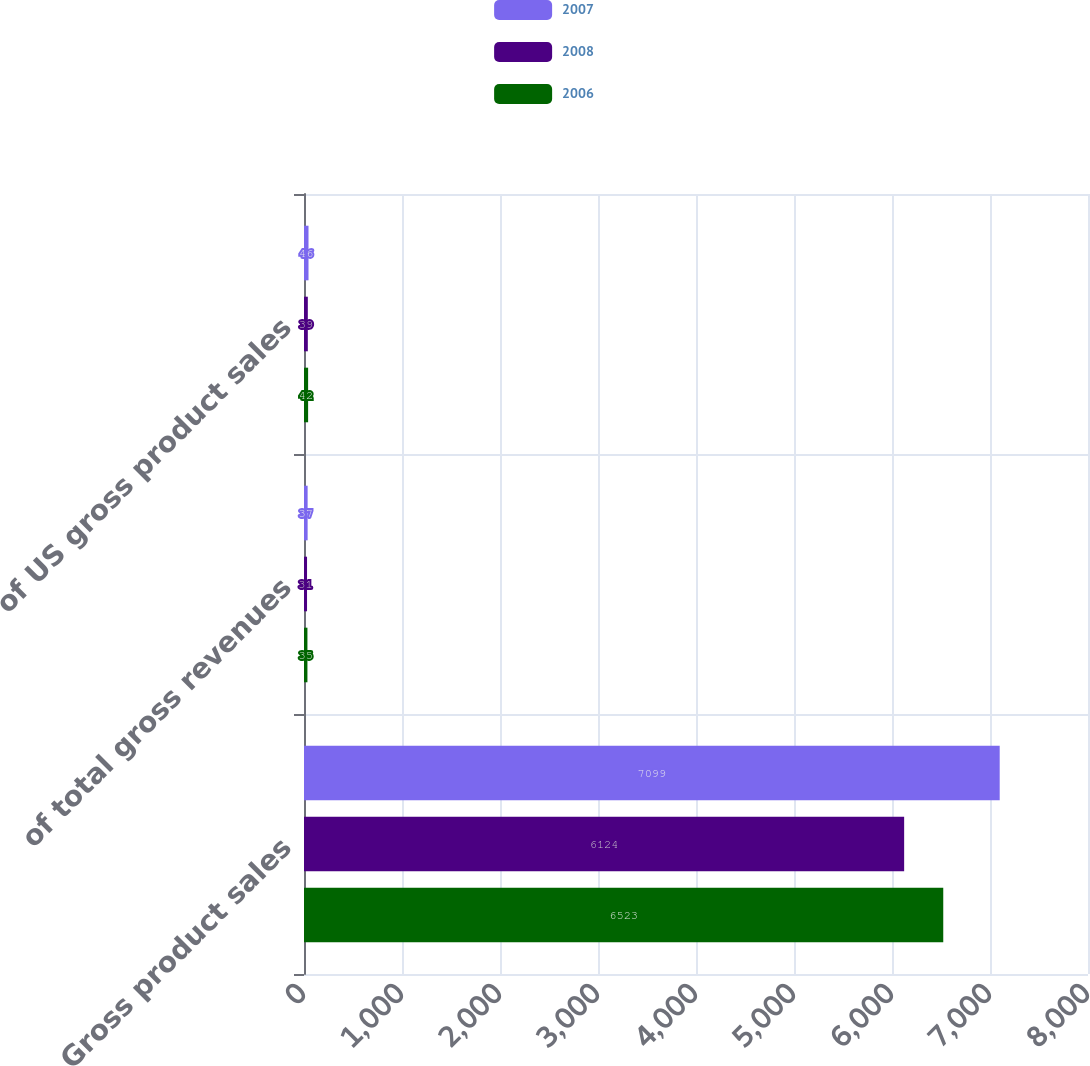Convert chart to OTSL. <chart><loc_0><loc_0><loc_500><loc_500><stacked_bar_chart><ecel><fcel>Gross product sales<fcel>of total gross revenues<fcel>of US gross product sales<nl><fcel>2007<fcel>7099<fcel>37<fcel>46<nl><fcel>2008<fcel>6124<fcel>31<fcel>39<nl><fcel>2006<fcel>6523<fcel>35<fcel>42<nl></chart> 